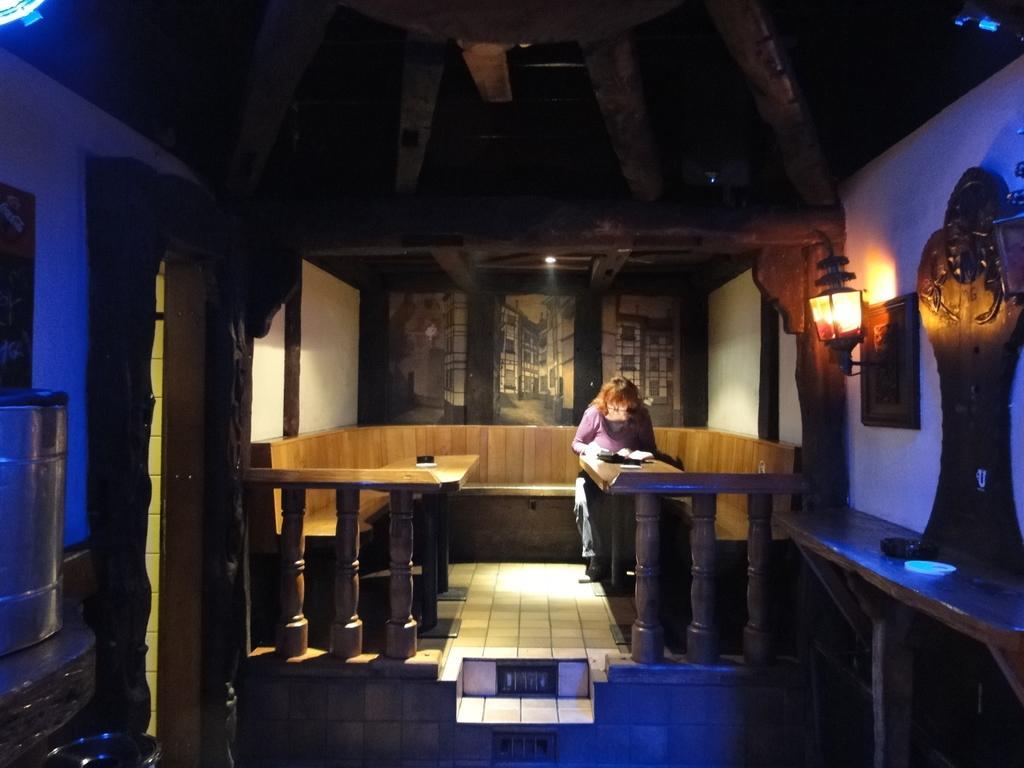Can you describe this image briefly? This picture is clicked inside the room. The woman in purple T-shirt is standing in front of the table. We see a black color thing is placed on the table. Behind her, we see a long wooden bench. In front of the table, we see railings. On the right side, we see a lantern and a photo frame placed on the wall. On the left side, we see a tin and a photo frame on the wall. In the background, we see photo frames or it might be a window from which buildings are visible. 